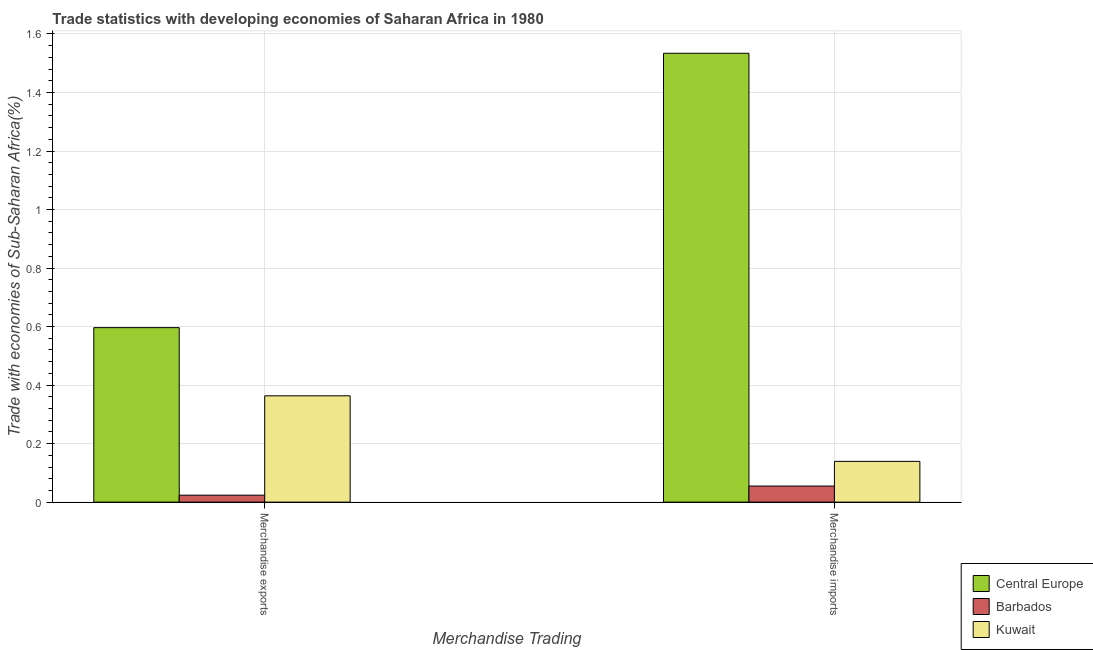How many different coloured bars are there?
Provide a succinct answer. 3. How many groups of bars are there?
Offer a very short reply. 2. Are the number of bars on each tick of the X-axis equal?
Make the answer very short. Yes. How many bars are there on the 1st tick from the left?
Make the answer very short. 3. How many bars are there on the 1st tick from the right?
Provide a short and direct response. 3. What is the merchandise imports in Barbados?
Your answer should be compact. 0.05. Across all countries, what is the maximum merchandise exports?
Your answer should be very brief. 0.6. Across all countries, what is the minimum merchandise imports?
Ensure brevity in your answer.  0.05. In which country was the merchandise imports maximum?
Provide a succinct answer. Central Europe. In which country was the merchandise exports minimum?
Make the answer very short. Barbados. What is the total merchandise exports in the graph?
Offer a terse response. 0.98. What is the difference between the merchandise exports in Central Europe and that in Barbados?
Offer a terse response. 0.57. What is the difference between the merchandise imports in Kuwait and the merchandise exports in Central Europe?
Your answer should be very brief. -0.46. What is the average merchandise exports per country?
Give a very brief answer. 0.33. What is the difference between the merchandise exports and merchandise imports in Central Europe?
Keep it short and to the point. -0.94. What is the ratio of the merchandise imports in Kuwait to that in Central Europe?
Make the answer very short. 0.09. Is the merchandise imports in Barbados less than that in Central Europe?
Ensure brevity in your answer.  Yes. What does the 2nd bar from the left in Merchandise exports represents?
Ensure brevity in your answer.  Barbados. What does the 3rd bar from the right in Merchandise imports represents?
Keep it short and to the point. Central Europe. How many countries are there in the graph?
Your answer should be very brief. 3. Does the graph contain any zero values?
Offer a terse response. No. What is the title of the graph?
Provide a short and direct response. Trade statistics with developing economies of Saharan Africa in 1980. Does "Yemen, Rep." appear as one of the legend labels in the graph?
Your response must be concise. No. What is the label or title of the X-axis?
Offer a very short reply. Merchandise Trading. What is the label or title of the Y-axis?
Your answer should be very brief. Trade with economies of Sub-Saharan Africa(%). What is the Trade with economies of Sub-Saharan Africa(%) in Central Europe in Merchandise exports?
Provide a short and direct response. 0.6. What is the Trade with economies of Sub-Saharan Africa(%) of Barbados in Merchandise exports?
Keep it short and to the point. 0.02. What is the Trade with economies of Sub-Saharan Africa(%) in Kuwait in Merchandise exports?
Ensure brevity in your answer.  0.36. What is the Trade with economies of Sub-Saharan Africa(%) in Central Europe in Merchandise imports?
Provide a short and direct response. 1.53. What is the Trade with economies of Sub-Saharan Africa(%) in Barbados in Merchandise imports?
Keep it short and to the point. 0.05. What is the Trade with economies of Sub-Saharan Africa(%) in Kuwait in Merchandise imports?
Offer a very short reply. 0.14. Across all Merchandise Trading, what is the maximum Trade with economies of Sub-Saharan Africa(%) in Central Europe?
Provide a succinct answer. 1.53. Across all Merchandise Trading, what is the maximum Trade with economies of Sub-Saharan Africa(%) of Barbados?
Ensure brevity in your answer.  0.05. Across all Merchandise Trading, what is the maximum Trade with economies of Sub-Saharan Africa(%) of Kuwait?
Provide a succinct answer. 0.36. Across all Merchandise Trading, what is the minimum Trade with economies of Sub-Saharan Africa(%) in Central Europe?
Provide a short and direct response. 0.6. Across all Merchandise Trading, what is the minimum Trade with economies of Sub-Saharan Africa(%) of Barbados?
Give a very brief answer. 0.02. Across all Merchandise Trading, what is the minimum Trade with economies of Sub-Saharan Africa(%) of Kuwait?
Your answer should be very brief. 0.14. What is the total Trade with economies of Sub-Saharan Africa(%) in Central Europe in the graph?
Make the answer very short. 2.13. What is the total Trade with economies of Sub-Saharan Africa(%) in Barbados in the graph?
Ensure brevity in your answer.  0.08. What is the total Trade with economies of Sub-Saharan Africa(%) in Kuwait in the graph?
Your answer should be compact. 0.5. What is the difference between the Trade with economies of Sub-Saharan Africa(%) in Central Europe in Merchandise exports and that in Merchandise imports?
Offer a terse response. -0.94. What is the difference between the Trade with economies of Sub-Saharan Africa(%) in Barbados in Merchandise exports and that in Merchandise imports?
Keep it short and to the point. -0.03. What is the difference between the Trade with economies of Sub-Saharan Africa(%) of Kuwait in Merchandise exports and that in Merchandise imports?
Make the answer very short. 0.22. What is the difference between the Trade with economies of Sub-Saharan Africa(%) of Central Europe in Merchandise exports and the Trade with economies of Sub-Saharan Africa(%) of Barbados in Merchandise imports?
Your answer should be very brief. 0.54. What is the difference between the Trade with economies of Sub-Saharan Africa(%) of Central Europe in Merchandise exports and the Trade with economies of Sub-Saharan Africa(%) of Kuwait in Merchandise imports?
Offer a terse response. 0.46. What is the difference between the Trade with economies of Sub-Saharan Africa(%) in Barbados in Merchandise exports and the Trade with economies of Sub-Saharan Africa(%) in Kuwait in Merchandise imports?
Your answer should be very brief. -0.12. What is the average Trade with economies of Sub-Saharan Africa(%) of Central Europe per Merchandise Trading?
Your answer should be very brief. 1.07. What is the average Trade with economies of Sub-Saharan Africa(%) of Barbados per Merchandise Trading?
Give a very brief answer. 0.04. What is the average Trade with economies of Sub-Saharan Africa(%) in Kuwait per Merchandise Trading?
Offer a very short reply. 0.25. What is the difference between the Trade with economies of Sub-Saharan Africa(%) of Central Europe and Trade with economies of Sub-Saharan Africa(%) of Barbados in Merchandise exports?
Your response must be concise. 0.57. What is the difference between the Trade with economies of Sub-Saharan Africa(%) of Central Europe and Trade with economies of Sub-Saharan Africa(%) of Kuwait in Merchandise exports?
Your answer should be compact. 0.23. What is the difference between the Trade with economies of Sub-Saharan Africa(%) in Barbados and Trade with economies of Sub-Saharan Africa(%) in Kuwait in Merchandise exports?
Provide a succinct answer. -0.34. What is the difference between the Trade with economies of Sub-Saharan Africa(%) in Central Europe and Trade with economies of Sub-Saharan Africa(%) in Barbados in Merchandise imports?
Your answer should be very brief. 1.48. What is the difference between the Trade with economies of Sub-Saharan Africa(%) in Central Europe and Trade with economies of Sub-Saharan Africa(%) in Kuwait in Merchandise imports?
Offer a very short reply. 1.39. What is the difference between the Trade with economies of Sub-Saharan Africa(%) in Barbados and Trade with economies of Sub-Saharan Africa(%) in Kuwait in Merchandise imports?
Offer a terse response. -0.08. What is the ratio of the Trade with economies of Sub-Saharan Africa(%) of Central Europe in Merchandise exports to that in Merchandise imports?
Your answer should be compact. 0.39. What is the ratio of the Trade with economies of Sub-Saharan Africa(%) in Barbados in Merchandise exports to that in Merchandise imports?
Provide a succinct answer. 0.43. What is the ratio of the Trade with economies of Sub-Saharan Africa(%) in Kuwait in Merchandise exports to that in Merchandise imports?
Make the answer very short. 2.61. What is the difference between the highest and the second highest Trade with economies of Sub-Saharan Africa(%) of Central Europe?
Offer a terse response. 0.94. What is the difference between the highest and the second highest Trade with economies of Sub-Saharan Africa(%) of Barbados?
Keep it short and to the point. 0.03. What is the difference between the highest and the second highest Trade with economies of Sub-Saharan Africa(%) in Kuwait?
Offer a terse response. 0.22. What is the difference between the highest and the lowest Trade with economies of Sub-Saharan Africa(%) of Central Europe?
Your answer should be very brief. 0.94. What is the difference between the highest and the lowest Trade with economies of Sub-Saharan Africa(%) of Barbados?
Make the answer very short. 0.03. What is the difference between the highest and the lowest Trade with economies of Sub-Saharan Africa(%) of Kuwait?
Offer a terse response. 0.22. 